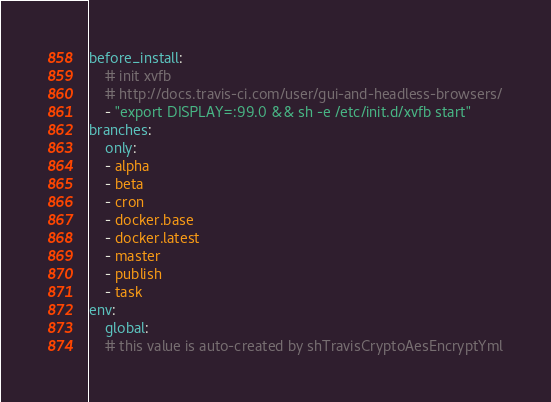Convert code to text. <code><loc_0><loc_0><loc_500><loc_500><_YAML_>before_install:
    # init xvfb
    # http://docs.travis-ci.com/user/gui-and-headless-browsers/
    - "export DISPLAY=:99.0 && sh -e /etc/init.d/xvfb start"
branches:
    only:
    - alpha
    - beta
    - cron
    - docker.base
    - docker.latest
    - master
    - publish
    - task
env:
    global:
    # this value is auto-created by shTravisCryptoAesEncryptYml</code> 